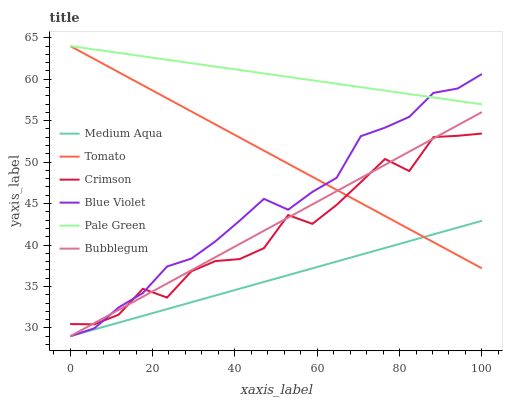Does Medium Aqua have the minimum area under the curve?
Answer yes or no. Yes. Does Pale Green have the maximum area under the curve?
Answer yes or no. Yes. Does Bubblegum have the minimum area under the curve?
Answer yes or no. No. Does Bubblegum have the maximum area under the curve?
Answer yes or no. No. Is Pale Green the smoothest?
Answer yes or no. Yes. Is Crimson the roughest?
Answer yes or no. Yes. Is Bubblegum the smoothest?
Answer yes or no. No. Is Bubblegum the roughest?
Answer yes or no. No. Does Bubblegum have the lowest value?
Answer yes or no. Yes. Does Pale Green have the lowest value?
Answer yes or no. No. Does Pale Green have the highest value?
Answer yes or no. Yes. Does Bubblegum have the highest value?
Answer yes or no. No. Is Bubblegum less than Pale Green?
Answer yes or no. Yes. Is Crimson greater than Medium Aqua?
Answer yes or no. Yes. Does Pale Green intersect Blue Violet?
Answer yes or no. Yes. Is Pale Green less than Blue Violet?
Answer yes or no. No. Is Pale Green greater than Blue Violet?
Answer yes or no. No. Does Bubblegum intersect Pale Green?
Answer yes or no. No. 